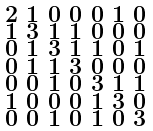Convert formula to latex. <formula><loc_0><loc_0><loc_500><loc_500>\begin{smallmatrix} 2 & 1 & 0 & 0 & 0 & 1 & 0 \\ 1 & 3 & 1 & 1 & 0 & 0 & 0 \\ 0 & 1 & 3 & 1 & 1 & 0 & 1 \\ 0 & 1 & 1 & 3 & 0 & 0 & 0 \\ 0 & 0 & 1 & 0 & 3 & 1 & 1 \\ 1 & 0 & 0 & 0 & 1 & 3 & 0 \\ 0 & 0 & 1 & 0 & 1 & 0 & 3 \end{smallmatrix}</formula> 